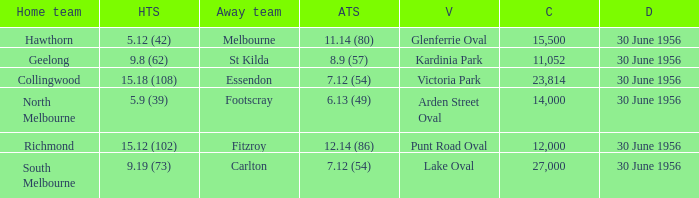What is the home team at Victoria Park with an Away team score of 7.12 (54) and more than 12,000 people? Collingwood. 